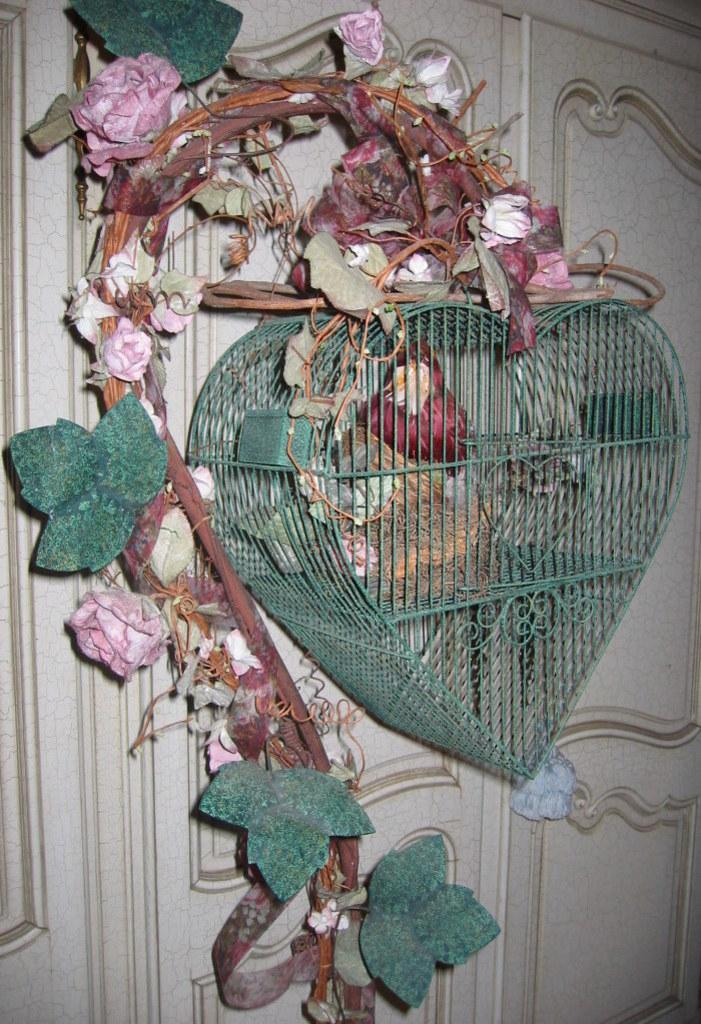What is located at the bottom of the image? There is an object at the bottom of the image. Can you describe anything in the background of the image? There is a door in the background of the image. What type of dirt can be seen on the train in the image? There is no train present in the image, so there is no dirt on a train to be observed. 